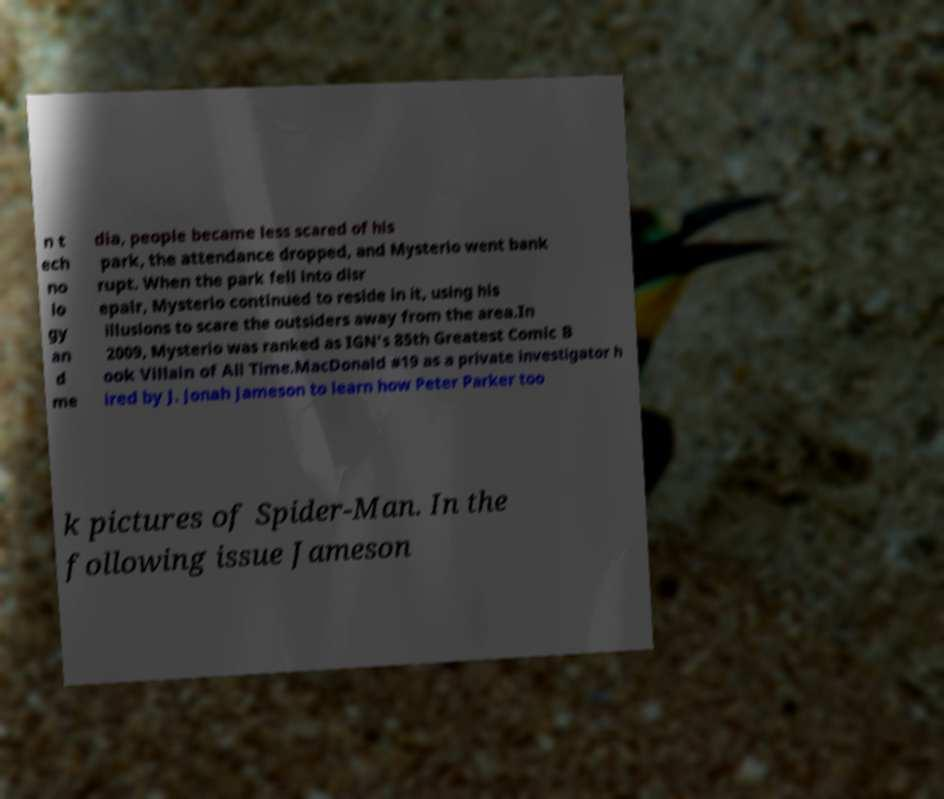Could you extract and type out the text from this image? n t ech no lo gy an d me dia, people became less scared of his park, the attendance dropped, and Mysterio went bank rupt. When the park fell into disr epair, Mysterio continued to reside in it, using his illusions to scare the outsiders away from the area.In 2009, Mysterio was ranked as IGN's 85th Greatest Comic B ook Villain of All Time.MacDonald #19 as a private investigator h ired by J. Jonah Jameson to learn how Peter Parker too k pictures of Spider-Man. In the following issue Jameson 